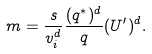Convert formula to latex. <formula><loc_0><loc_0><loc_500><loc_500>m = \frac { s } { v _ { i } ^ { d } } \frac { ( q ^ { * } ) ^ { d } } { q } ( U ^ { \prime } ) ^ { d } .</formula> 